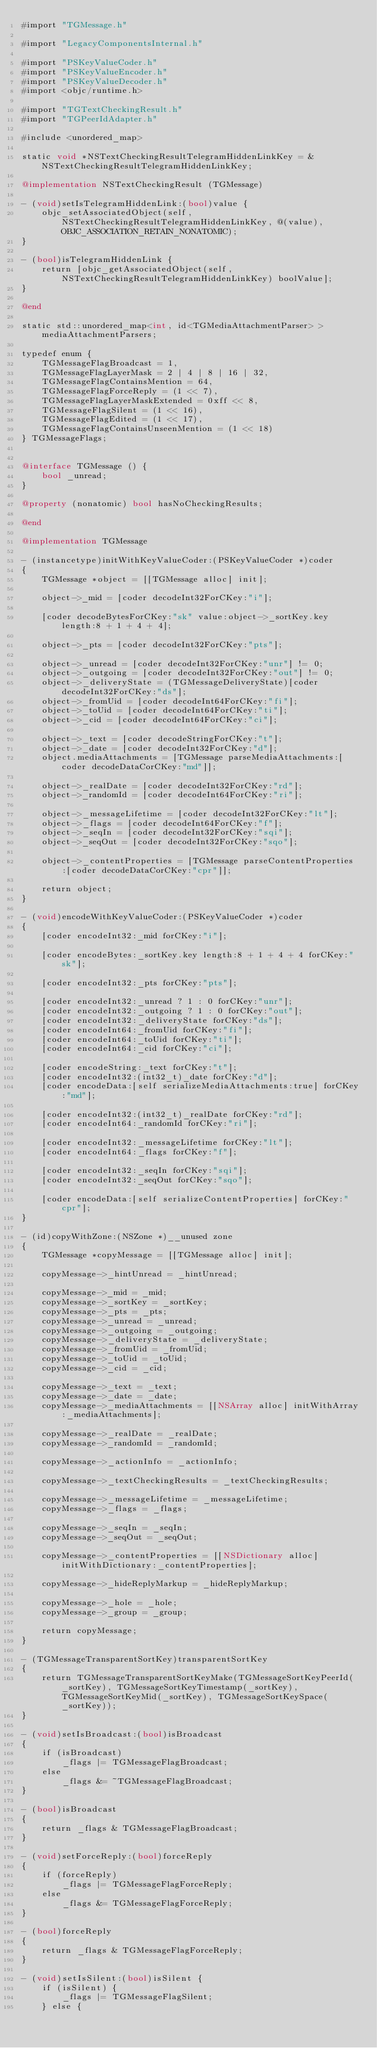<code> <loc_0><loc_0><loc_500><loc_500><_ObjectiveC_>#import "TGMessage.h"

#import "LegacyComponentsInternal.h"

#import "PSKeyValueCoder.h"
#import "PSKeyValueEncoder.h"
#import "PSKeyValueDecoder.h"
#import <objc/runtime.h>

#import "TGTextCheckingResult.h"
#import "TGPeerIdAdapter.h"

#include <unordered_map>

static void *NSTextCheckingResultTelegramHiddenLinkKey = &NSTextCheckingResultTelegramHiddenLinkKey;

@implementation NSTextCheckingResult (TGMessage)

- (void)setIsTelegramHiddenLink:(bool)value {
    objc_setAssociatedObject(self, NSTextCheckingResultTelegramHiddenLinkKey, @(value), OBJC_ASSOCIATION_RETAIN_NONATOMIC);
}

- (bool)isTelegramHiddenLink {
    return [objc_getAssociatedObject(self, NSTextCheckingResultTelegramHiddenLinkKey) boolValue];
}

@end

static std::unordered_map<int, id<TGMediaAttachmentParser> > mediaAttachmentParsers;

typedef enum {
    TGMessageFlagBroadcast = 1,
    TGMessageFlagLayerMask = 2 | 4 | 8 | 16 | 32,
    TGMessageFlagContainsMention = 64,
    TGMessageFlagForceReply = (1 << 7),
    TGMessageFlagLayerMaskExtended = 0xff << 8,
    TGMessageFlagSilent = (1 << 16),
    TGMessageFlagEdited = (1 << 17),
    TGMessageFlagContainsUnseenMention = (1 << 18)
} TGMessageFlags;


@interface TGMessage () {
    bool _unread;
}

@property (nonatomic) bool hasNoCheckingResults;

@end

@implementation TGMessage

- (instancetype)initWithKeyValueCoder:(PSKeyValueCoder *)coder
{
    TGMessage *object = [[TGMessage alloc] init];
    
    object->_mid = [coder decodeInt32ForCKey:"i"];
    
    [coder decodeBytesForCKey:"sk" value:object->_sortKey.key length:8 + 1 + 4 + 4];
    
    object->_pts = [coder decodeInt32ForCKey:"pts"];
    
    object->_unread = [coder decodeInt32ForCKey:"unr"] != 0;
    object->_outgoing = [coder decodeInt32ForCKey:"out"] != 0;
    object->_deliveryState = (TGMessageDeliveryState)[coder decodeInt32ForCKey:"ds"];
    object->_fromUid = [coder decodeInt64ForCKey:"fi"];
    object->_toUid = [coder decodeInt64ForCKey:"ti"];
    object->_cid = [coder decodeInt64ForCKey:"ci"];
    
    object->_text = [coder decodeStringForCKey:"t"];
    object->_date = [coder decodeInt32ForCKey:"d"];
    object.mediaAttachments = [TGMessage parseMediaAttachments:[coder decodeDataCorCKey:"md"]];
    
    object->_realDate = [coder decodeInt32ForCKey:"rd"];
    object->_randomId = [coder decodeInt64ForCKey:"ri"];
    
    object->_messageLifetime = [coder decodeInt32ForCKey:"lt"];
    object->_flags = [coder decodeInt64ForCKey:"f"];
    object->_seqIn = [coder decodeInt32ForCKey:"sqi"];
    object->_seqOut = [coder decodeInt32ForCKey:"sqo"];
    
    object->_contentProperties = [TGMessage parseContentProperties:[coder decodeDataCorCKey:"cpr"]];
    
    return object;
}

- (void)encodeWithKeyValueCoder:(PSKeyValueCoder *)coder
{
    [coder encodeInt32:_mid forCKey:"i"];
    
    [coder encodeBytes:_sortKey.key length:8 + 1 + 4 + 4 forCKey:"sk"];
    
    [coder encodeInt32:_pts forCKey:"pts"];
    
    [coder encodeInt32:_unread ? 1 : 0 forCKey:"unr"];
    [coder encodeInt32:_outgoing ? 1 : 0 forCKey:"out"];
    [coder encodeInt32:_deliveryState forCKey:"ds"];
    [coder encodeInt64:_fromUid forCKey:"fi"];
    [coder encodeInt64:_toUid forCKey:"ti"];
    [coder encodeInt64:_cid forCKey:"ci"];
    
    [coder encodeString:_text forCKey:"t"];
    [coder encodeInt32:(int32_t)_date forCKey:"d"];
    [coder encodeData:[self serializeMediaAttachments:true] forCKey:"md"];
    
    [coder encodeInt32:(int32_t)_realDate forCKey:"rd"];
    [coder encodeInt64:_randomId forCKey:"ri"];
    
    [coder encodeInt32:_messageLifetime forCKey:"lt"];
    [coder encodeInt64:_flags forCKey:"f"];
    
    [coder encodeInt32:_seqIn forCKey:"sqi"];
    [coder encodeInt32:_seqOut forCKey:"sqo"];
    
    [coder encodeData:[self serializeContentProperties] forCKey:"cpr"];
}

- (id)copyWithZone:(NSZone *)__unused zone
{
    TGMessage *copyMessage = [[TGMessage alloc] init];
    
    copyMessage->_hintUnread = _hintUnread;
    
    copyMessage->_mid = _mid;
    copyMessage->_sortKey = _sortKey;
    copyMessage->_pts = _pts;
    copyMessage->_unread = _unread;
    copyMessage->_outgoing = _outgoing;
    copyMessage->_deliveryState = _deliveryState;
    copyMessage->_fromUid = _fromUid;
    copyMessage->_toUid = _toUid;
    copyMessage->_cid = _cid;
    
    copyMessage->_text = _text;
    copyMessage->_date = _date;
    copyMessage->_mediaAttachments = [[NSArray alloc] initWithArray:_mediaAttachments];
    
    copyMessage->_realDate = _realDate;
    copyMessage->_randomId = _randomId;
    
    copyMessage->_actionInfo = _actionInfo;
    
    copyMessage->_textCheckingResults = _textCheckingResults;
    
    copyMessage->_messageLifetime = _messageLifetime;
    copyMessage->_flags = _flags;
    
    copyMessage->_seqIn = _seqIn;
    copyMessage->_seqOut = _seqOut;
    
    copyMessage->_contentProperties = [[NSDictionary alloc] initWithDictionary:_contentProperties];
    
    copyMessage->_hideReplyMarkup = _hideReplyMarkup;
    
    copyMessage->_hole = _hole;
    copyMessage->_group = _group;
    
    return copyMessage;
}

- (TGMessageTransparentSortKey)transparentSortKey
{
    return TGMessageTransparentSortKeyMake(TGMessageSortKeyPeerId(_sortKey), TGMessageSortKeyTimestamp(_sortKey), TGMessageSortKeyMid(_sortKey), TGMessageSortKeySpace(_sortKey));
}

- (void)setIsBroadcast:(bool)isBroadcast
{
    if (isBroadcast)
        _flags |= TGMessageFlagBroadcast;
    else
        _flags &= ~TGMessageFlagBroadcast;
}

- (bool)isBroadcast
{
    return _flags & TGMessageFlagBroadcast;
}

- (void)setForceReply:(bool)forceReply
{
    if (forceReply)
        _flags |= TGMessageFlagForceReply;
    else
        _flags &= TGMessageFlagForceReply;
}

- (bool)forceReply
{
    return _flags & TGMessageFlagForceReply;
}

- (void)setIsSilent:(bool)isSilent {
    if (isSilent) {
        _flags |= TGMessageFlagSilent;
    } else {</code> 